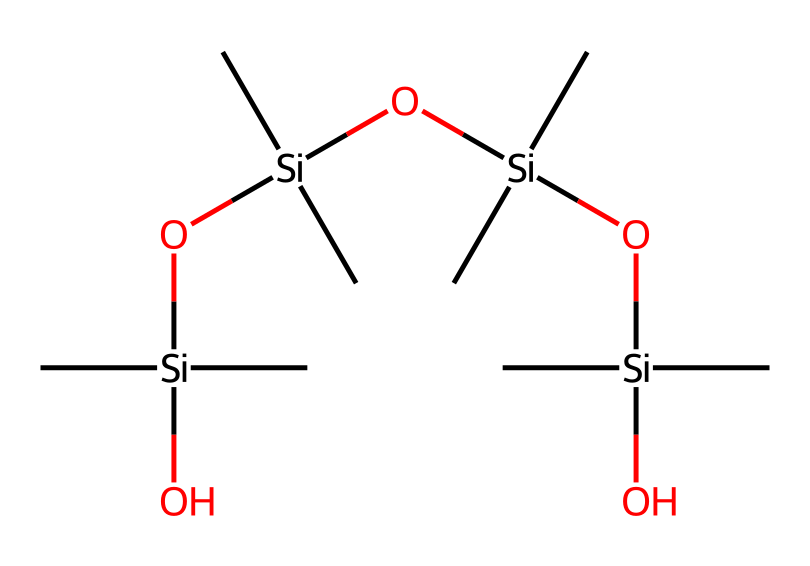how many silicon atoms are present? The chemical structure indicates that there are four distinct silicon atoms, each represented by the symbol "Si." Counting them in the SMILES representation shows that there is one central silicon atom and three more silicon atoms bonded through silicon-oxygen linkages.
Answer: four what functional groups are present? The structure includes several hydroxyl (–OH) groups attached to the silicon atoms, making them functional groups. Additionally, the siloxane (silicon-oxygen) linkages also define this type of organosilicon compound.
Answer: hydroxyl, siloxane what is the type of this compound? The structure indicates that this is an organosilicon compound due to the presence of carbon (C) and silicon (Si) atoms bonded through siloxane linkages, which is characteristic of silicones.
Answer: organosilicon how many oxygen atoms are present in the molecule? In the SMILES representation, there are four oxygen atoms directly indicated by "O" in the connections with silicon, each forming part of the siloxane linkages or hydroxyl groups. Counting each "O" gives a total of four oxygen atoms.
Answer: four what property does this compound likely have? Given the presence of multiple siloxane and hydroxyl groups, this compound is likely to exhibit water-repellent properties, as organosilicon compounds are known for their hydrophobic characteristics.
Answer: water-repellent how many carbon atoms are present? The chemical structure displays 12 carbon atoms, each represented by "C." By counting the occurrences of "C" in the SMILES notation, it's confirmed that the total count of carbon atoms is 12.
Answer: twelve 